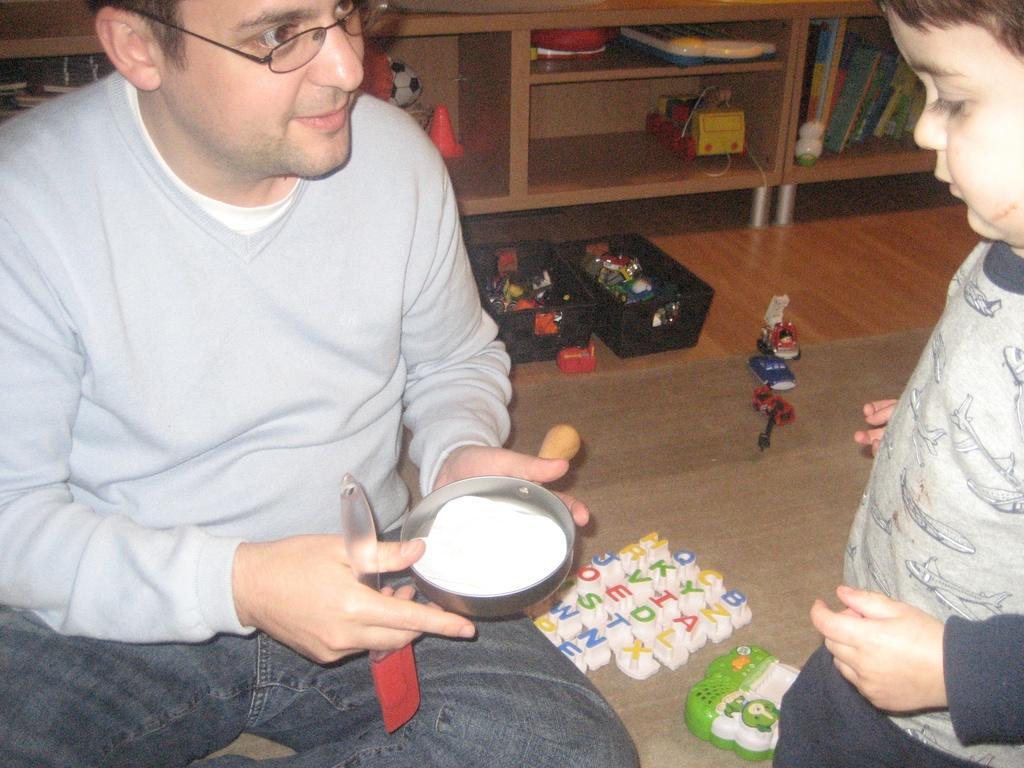In one or two sentences, can you explain what this image depicts? In this picture I can see a kid standing. There is a man sitting and holding a pastry brush and an object. I can see toys, baskets, books and some other objects. 